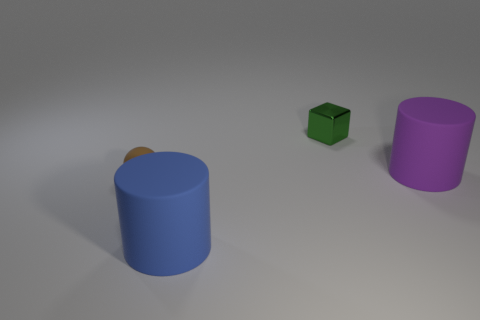There is another object that is the same size as the blue matte object; what is its material?
Make the answer very short. Rubber. Are there any big matte cubes of the same color as the tiny metallic block?
Provide a short and direct response. No. There is a object that is behind the small matte thing and in front of the block; what shape is it?
Give a very brief answer. Cylinder. What number of spheres are the same material as the blue object?
Your answer should be very brief. 1. Is the number of green cubes that are in front of the small green metallic object less than the number of brown balls that are to the right of the big blue rubber cylinder?
Give a very brief answer. No. What is the material of the cylinder that is in front of the big cylinder behind the large cylinder in front of the small matte sphere?
Give a very brief answer. Rubber. How big is the thing that is both in front of the green metallic block and behind the small brown matte sphere?
Make the answer very short. Large. How many cylinders are purple rubber objects or large blue things?
Ensure brevity in your answer.  2. The object that is the same size as the green cube is what color?
Your response must be concise. Brown. Is there any other thing that is the same shape as the big blue thing?
Provide a short and direct response. Yes. 